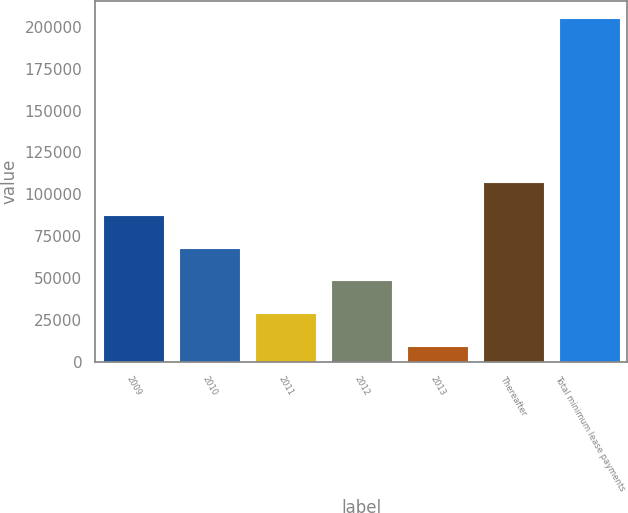Convert chart to OTSL. <chart><loc_0><loc_0><loc_500><loc_500><bar_chart><fcel>2009<fcel>2010<fcel>2011<fcel>2012<fcel>2013<fcel>Thereafter<fcel>Total minimum lease payments<nl><fcel>87740.6<fcel>68160.2<fcel>28999.4<fcel>48579.8<fcel>9419<fcel>107321<fcel>205223<nl></chart> 